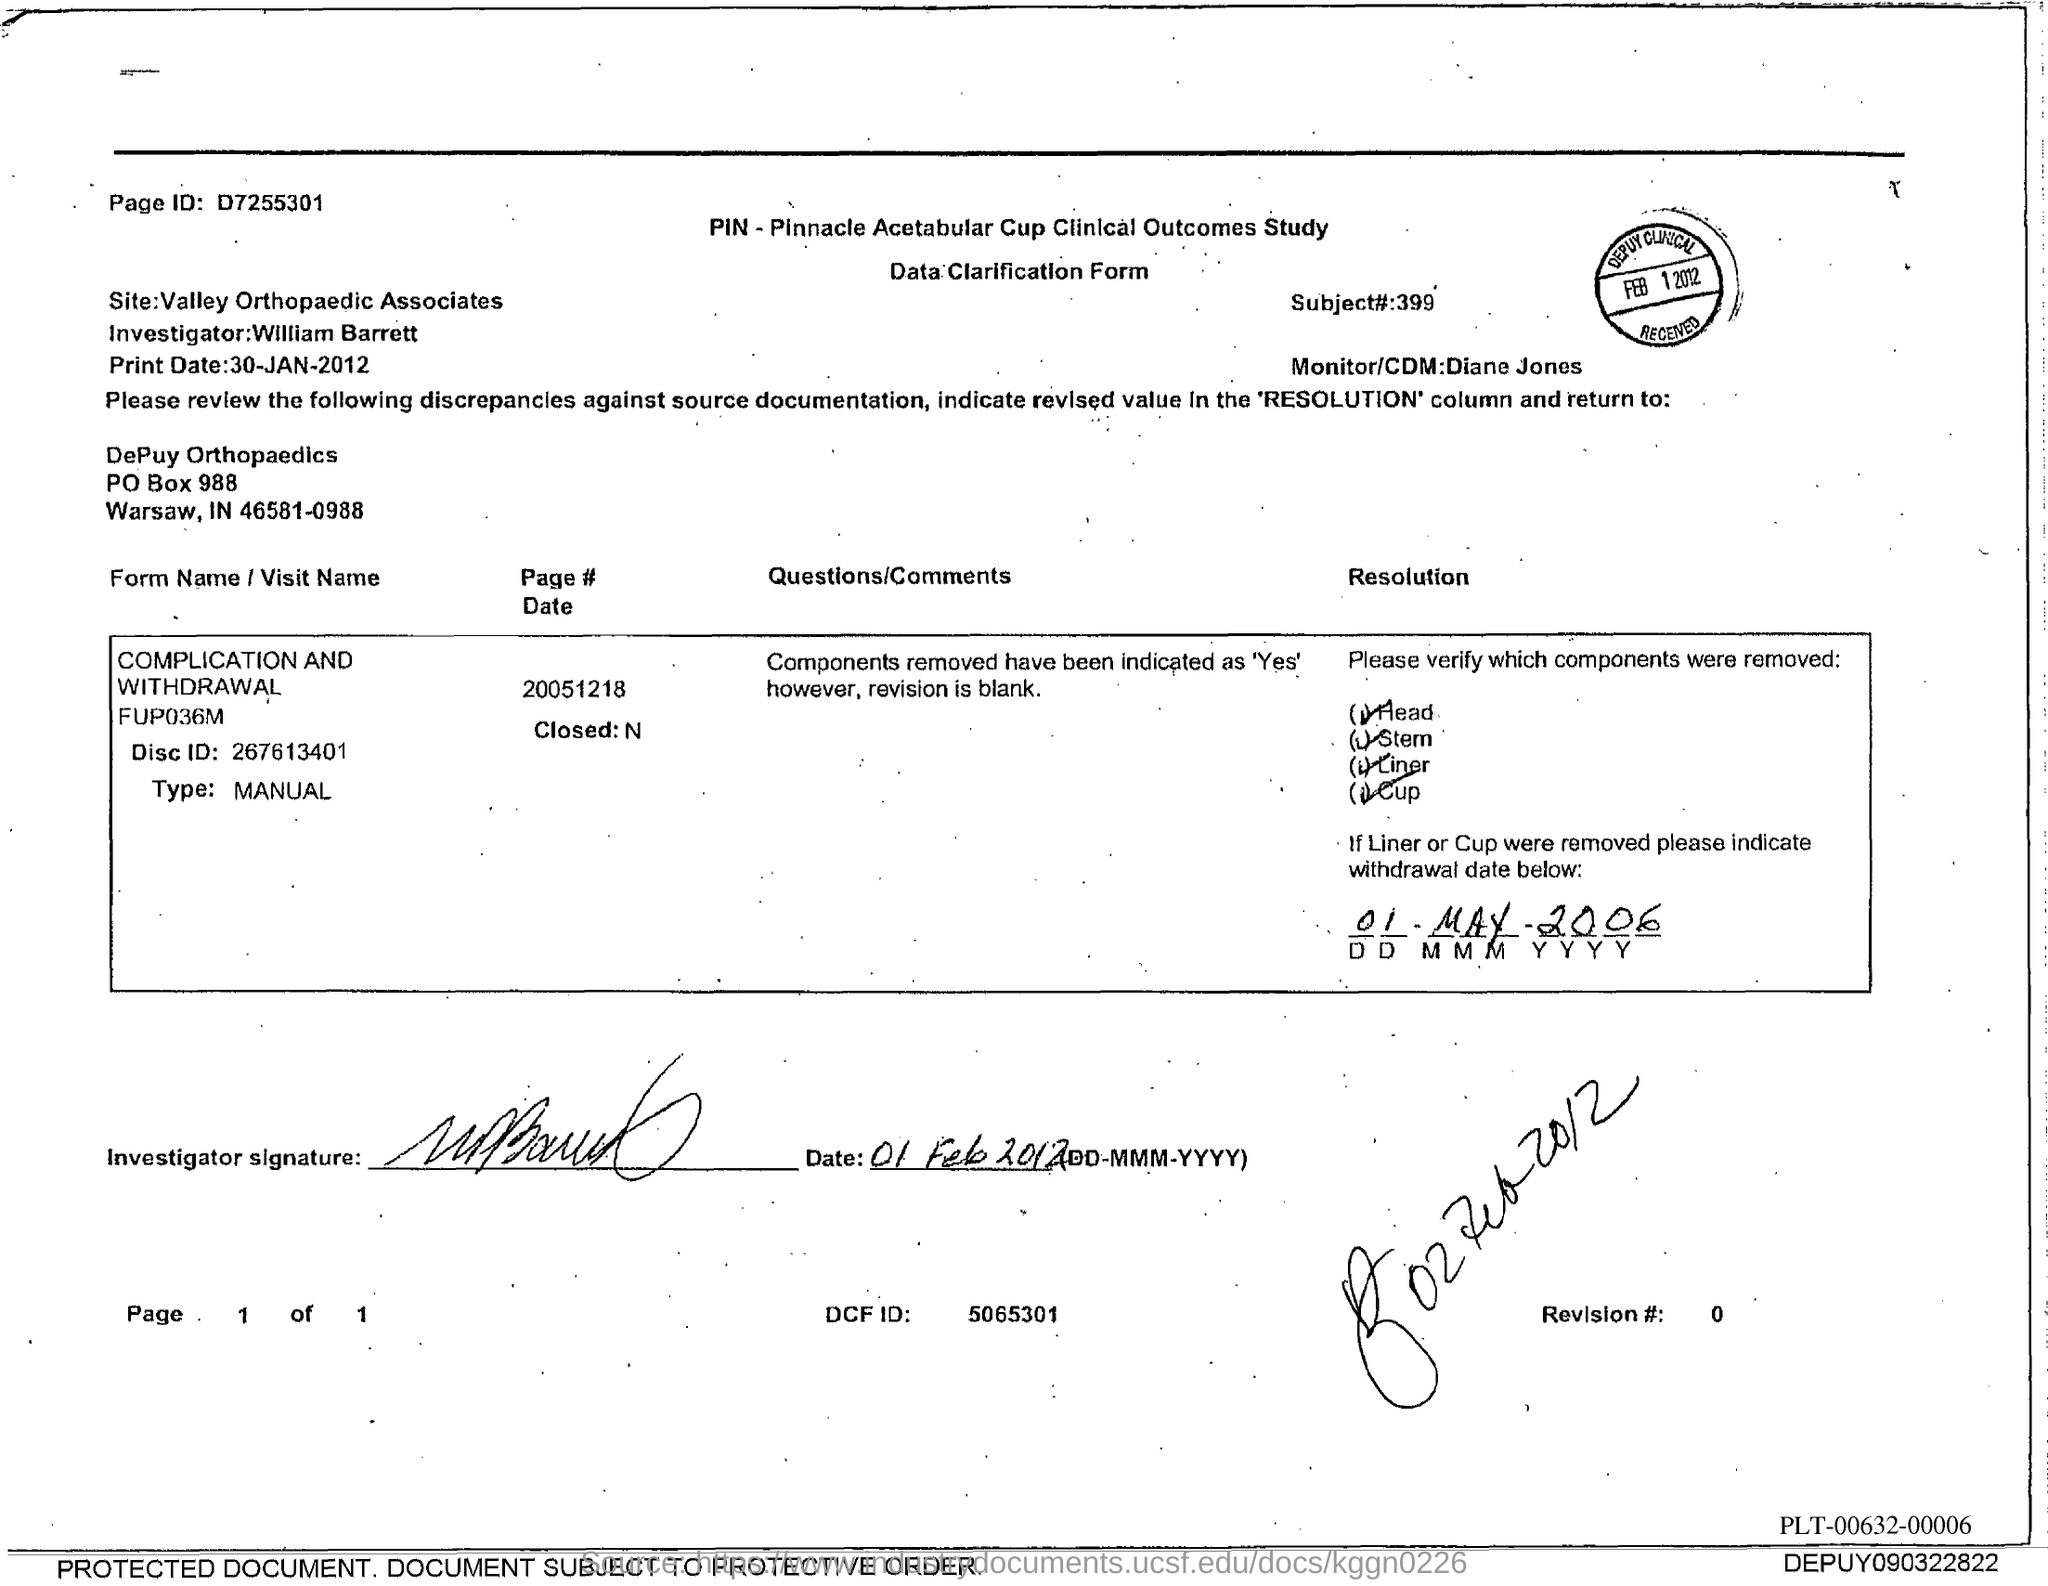Who is the Monitor/CDM?
Ensure brevity in your answer.  Diane Jones. What is the Subject# number?
Offer a terse response. 399. Who is the Investigator?
Offer a very short reply. William Barrett. Which site is mentioned in the document?
Your answer should be compact. Valley Orthopaedic Associates. What is the Disc id?
Provide a succinct answer. 267613401. What is the PO Box Number mentioned in the document?
Your answer should be very brief. 988. What is the page id?
Keep it short and to the point. D7255301. 